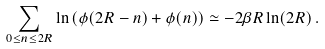<formula> <loc_0><loc_0><loc_500><loc_500>\sum _ { 0 \leq n \leq 2 R } \ln \left ( \phi ( 2 R - n ) + \phi ( n ) \right ) \simeq - 2 \beta R \ln ( 2 R ) \, .</formula> 